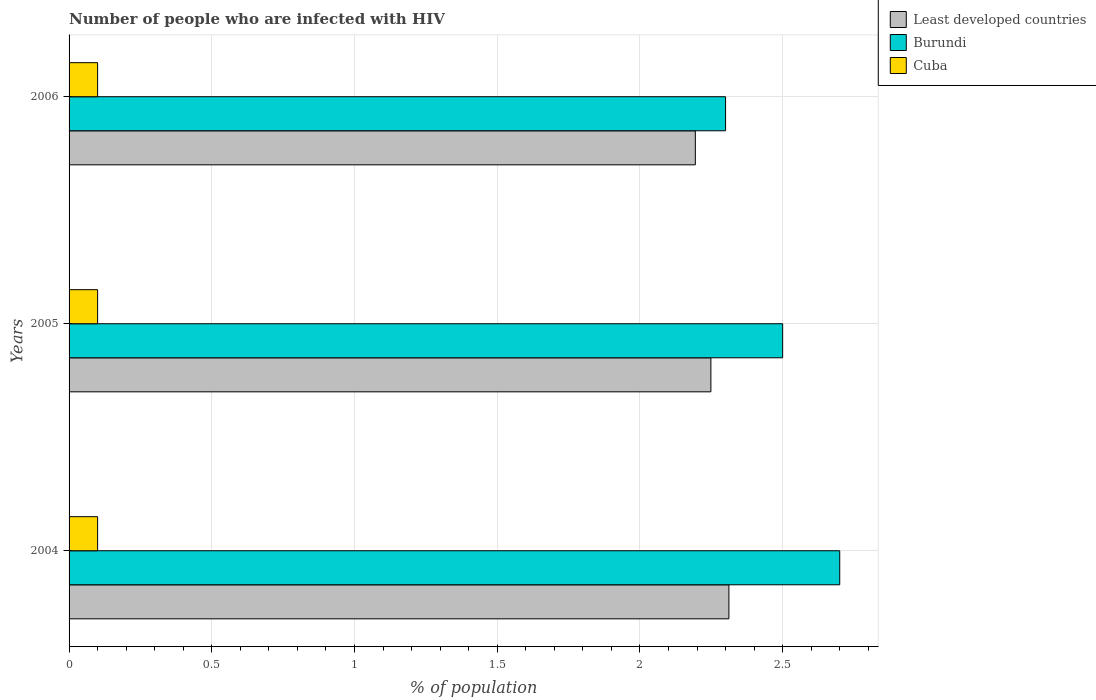How many groups of bars are there?
Provide a succinct answer. 3. Are the number of bars per tick equal to the number of legend labels?
Provide a short and direct response. Yes. Are the number of bars on each tick of the Y-axis equal?
Give a very brief answer. Yes. How many bars are there on the 3rd tick from the top?
Give a very brief answer. 3. How many bars are there on the 3rd tick from the bottom?
Keep it short and to the point. 3. What is the label of the 3rd group of bars from the top?
Ensure brevity in your answer.  2004. Across all years, what is the minimum percentage of HIV infected population in in Burundi?
Ensure brevity in your answer.  2.3. In which year was the percentage of HIV infected population in in Burundi maximum?
Keep it short and to the point. 2004. What is the total percentage of HIV infected population in in Cuba in the graph?
Your response must be concise. 0.3. What is the difference between the percentage of HIV infected population in in Least developed countries in 2004 and that in 2005?
Provide a succinct answer. 0.06. What is the difference between the percentage of HIV infected population in in Burundi in 2004 and the percentage of HIV infected population in in Least developed countries in 2006?
Provide a short and direct response. 0.51. What is the average percentage of HIV infected population in in Least developed countries per year?
Keep it short and to the point. 2.25. In the year 2006, what is the difference between the percentage of HIV infected population in in Least developed countries and percentage of HIV infected population in in Burundi?
Make the answer very short. -0.11. What is the ratio of the percentage of HIV infected population in in Least developed countries in 2004 to that in 2005?
Your answer should be very brief. 1.03. Is the difference between the percentage of HIV infected population in in Least developed countries in 2005 and 2006 greater than the difference between the percentage of HIV infected population in in Burundi in 2005 and 2006?
Provide a short and direct response. No. What is the difference between the highest and the second highest percentage of HIV infected population in in Burundi?
Your answer should be compact. 0.2. What is the difference between the highest and the lowest percentage of HIV infected population in in Burundi?
Your answer should be very brief. 0.4. Is the sum of the percentage of HIV infected population in in Least developed countries in 2005 and 2006 greater than the maximum percentage of HIV infected population in in Cuba across all years?
Keep it short and to the point. Yes. What does the 1st bar from the top in 2004 represents?
Provide a succinct answer. Cuba. What does the 3rd bar from the bottom in 2005 represents?
Provide a succinct answer. Cuba. Is it the case that in every year, the sum of the percentage of HIV infected population in in Burundi and percentage of HIV infected population in in Cuba is greater than the percentage of HIV infected population in in Least developed countries?
Keep it short and to the point. Yes. How many years are there in the graph?
Your answer should be compact. 3. What is the difference between two consecutive major ticks on the X-axis?
Your answer should be compact. 0.5. Where does the legend appear in the graph?
Keep it short and to the point. Top right. How many legend labels are there?
Give a very brief answer. 3. What is the title of the graph?
Offer a very short reply. Number of people who are infected with HIV. What is the label or title of the X-axis?
Your answer should be very brief. % of population. What is the label or title of the Y-axis?
Your answer should be very brief. Years. What is the % of population in Least developed countries in 2004?
Provide a succinct answer. 2.31. What is the % of population of Burundi in 2004?
Give a very brief answer. 2.7. What is the % of population of Cuba in 2004?
Your answer should be very brief. 0.1. What is the % of population in Least developed countries in 2005?
Keep it short and to the point. 2.25. What is the % of population of Burundi in 2005?
Provide a succinct answer. 2.5. What is the % of population in Cuba in 2005?
Offer a terse response. 0.1. What is the % of population in Least developed countries in 2006?
Your answer should be very brief. 2.19. Across all years, what is the maximum % of population in Least developed countries?
Your answer should be very brief. 2.31. Across all years, what is the minimum % of population in Least developed countries?
Ensure brevity in your answer.  2.19. Across all years, what is the minimum % of population in Burundi?
Offer a terse response. 2.3. What is the total % of population in Least developed countries in the graph?
Your response must be concise. 6.75. What is the total % of population of Cuba in the graph?
Give a very brief answer. 0.3. What is the difference between the % of population of Least developed countries in 2004 and that in 2005?
Offer a very short reply. 0.06. What is the difference between the % of population of Burundi in 2004 and that in 2005?
Keep it short and to the point. 0.2. What is the difference between the % of population of Cuba in 2004 and that in 2005?
Give a very brief answer. 0. What is the difference between the % of population of Least developed countries in 2004 and that in 2006?
Offer a very short reply. 0.12. What is the difference between the % of population of Burundi in 2004 and that in 2006?
Your response must be concise. 0.4. What is the difference between the % of population of Least developed countries in 2005 and that in 2006?
Provide a succinct answer. 0.05. What is the difference between the % of population in Least developed countries in 2004 and the % of population in Burundi in 2005?
Your answer should be very brief. -0.19. What is the difference between the % of population in Least developed countries in 2004 and the % of population in Cuba in 2005?
Provide a short and direct response. 2.21. What is the difference between the % of population of Burundi in 2004 and the % of population of Cuba in 2005?
Your response must be concise. 2.6. What is the difference between the % of population of Least developed countries in 2004 and the % of population of Burundi in 2006?
Your response must be concise. 0.01. What is the difference between the % of population in Least developed countries in 2004 and the % of population in Cuba in 2006?
Provide a succinct answer. 2.21. What is the difference between the % of population in Least developed countries in 2005 and the % of population in Burundi in 2006?
Give a very brief answer. -0.05. What is the difference between the % of population of Least developed countries in 2005 and the % of population of Cuba in 2006?
Give a very brief answer. 2.15. What is the average % of population in Least developed countries per year?
Offer a very short reply. 2.25. What is the average % of population of Cuba per year?
Your response must be concise. 0.1. In the year 2004, what is the difference between the % of population in Least developed countries and % of population in Burundi?
Provide a short and direct response. -0.39. In the year 2004, what is the difference between the % of population in Least developed countries and % of population in Cuba?
Ensure brevity in your answer.  2.21. In the year 2004, what is the difference between the % of population in Burundi and % of population in Cuba?
Provide a succinct answer. 2.6. In the year 2005, what is the difference between the % of population of Least developed countries and % of population of Burundi?
Keep it short and to the point. -0.25. In the year 2005, what is the difference between the % of population of Least developed countries and % of population of Cuba?
Provide a short and direct response. 2.15. In the year 2005, what is the difference between the % of population in Burundi and % of population in Cuba?
Keep it short and to the point. 2.4. In the year 2006, what is the difference between the % of population in Least developed countries and % of population in Burundi?
Offer a terse response. -0.11. In the year 2006, what is the difference between the % of population of Least developed countries and % of population of Cuba?
Provide a succinct answer. 2.09. In the year 2006, what is the difference between the % of population in Burundi and % of population in Cuba?
Keep it short and to the point. 2.2. What is the ratio of the % of population of Least developed countries in 2004 to that in 2005?
Your response must be concise. 1.03. What is the ratio of the % of population of Burundi in 2004 to that in 2005?
Make the answer very short. 1.08. What is the ratio of the % of population of Cuba in 2004 to that in 2005?
Offer a terse response. 1. What is the ratio of the % of population of Least developed countries in 2004 to that in 2006?
Provide a succinct answer. 1.05. What is the ratio of the % of population in Burundi in 2004 to that in 2006?
Provide a short and direct response. 1.17. What is the ratio of the % of population in Cuba in 2004 to that in 2006?
Keep it short and to the point. 1. What is the ratio of the % of population in Least developed countries in 2005 to that in 2006?
Make the answer very short. 1.02. What is the ratio of the % of population in Burundi in 2005 to that in 2006?
Provide a succinct answer. 1.09. What is the ratio of the % of population in Cuba in 2005 to that in 2006?
Ensure brevity in your answer.  1. What is the difference between the highest and the second highest % of population of Least developed countries?
Your answer should be compact. 0.06. What is the difference between the highest and the second highest % of population in Cuba?
Your answer should be very brief. 0. What is the difference between the highest and the lowest % of population in Least developed countries?
Your answer should be compact. 0.12. What is the difference between the highest and the lowest % of population of Burundi?
Provide a short and direct response. 0.4. 